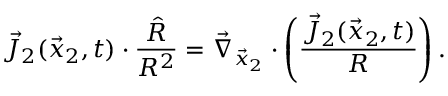Convert formula to latex. <formula><loc_0><loc_0><loc_500><loc_500>\vec { J } _ { 2 } ( \vec { x } _ { 2 } , t ) \cdot \frac { \hat { R } } { R ^ { 2 } } = \vec { \nabla } _ { \vec { x } _ { 2 } } \cdot \left ( \frac { \vec { J } _ { 2 } ( \vec { x } _ { 2 } , t ) } { R } \right ) .</formula> 